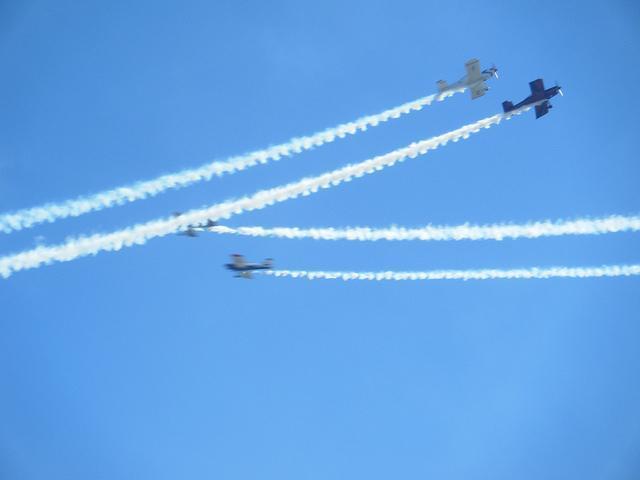How many people are wearing cap?
Give a very brief answer. 0. 